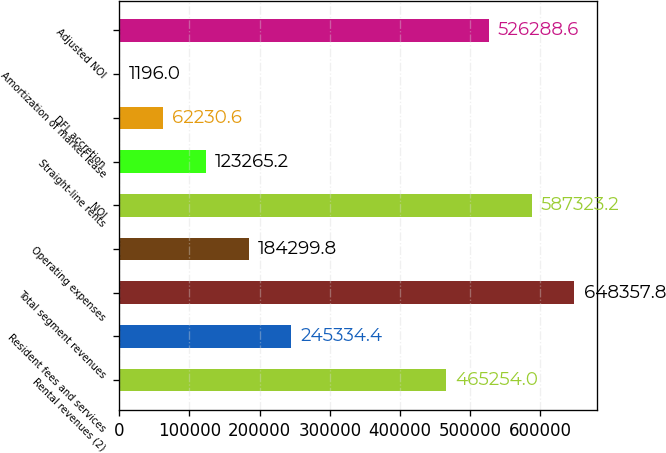<chart> <loc_0><loc_0><loc_500><loc_500><bar_chart><fcel>Rental revenues (2)<fcel>Resident fees and services<fcel>Total segment revenues<fcel>Operating expenses<fcel>NOI<fcel>Straight-line rents<fcel>DFL accretion<fcel>Amortization of market lease<fcel>Adjusted NOI<nl><fcel>465254<fcel>245334<fcel>648358<fcel>184300<fcel>587323<fcel>123265<fcel>62230.6<fcel>1196<fcel>526289<nl></chart> 